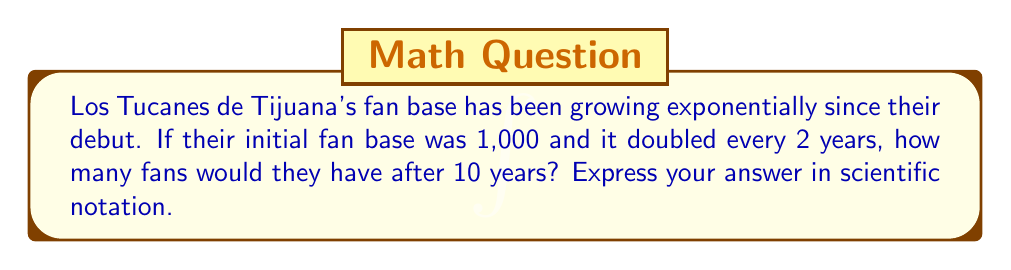Teach me how to tackle this problem. Let's approach this step-by-step:

1) We start with the exponential growth formula:
   $A = P(1+r)^t$
   Where:
   $A$ = final amount
   $P$ = initial amount
   $r$ = growth rate
   $t$ = time periods

2) We know:
   $P = 1,000$ (initial fan base)
   The fan base doubles every 2 years, so $r = 1$ (100% growth)
   $t = 5$ (10 years ÷ 2 years per doubling)

3) Let's plug these values into our formula:
   $A = 1,000(1+1)^5$

4) Simplify:
   $A = 1,000(2)^5$

5) Calculate:
   $A = 1,000 \cdot 32 = 32,000$

6) Convert to scientific notation:
   $32,000 = 3.2 \times 10^4$

Therefore, after 10 years, Los Tucanes de Tijuana would have $3.2 \times 10^4$ fans.
Answer: $3.2 \times 10^4$ 